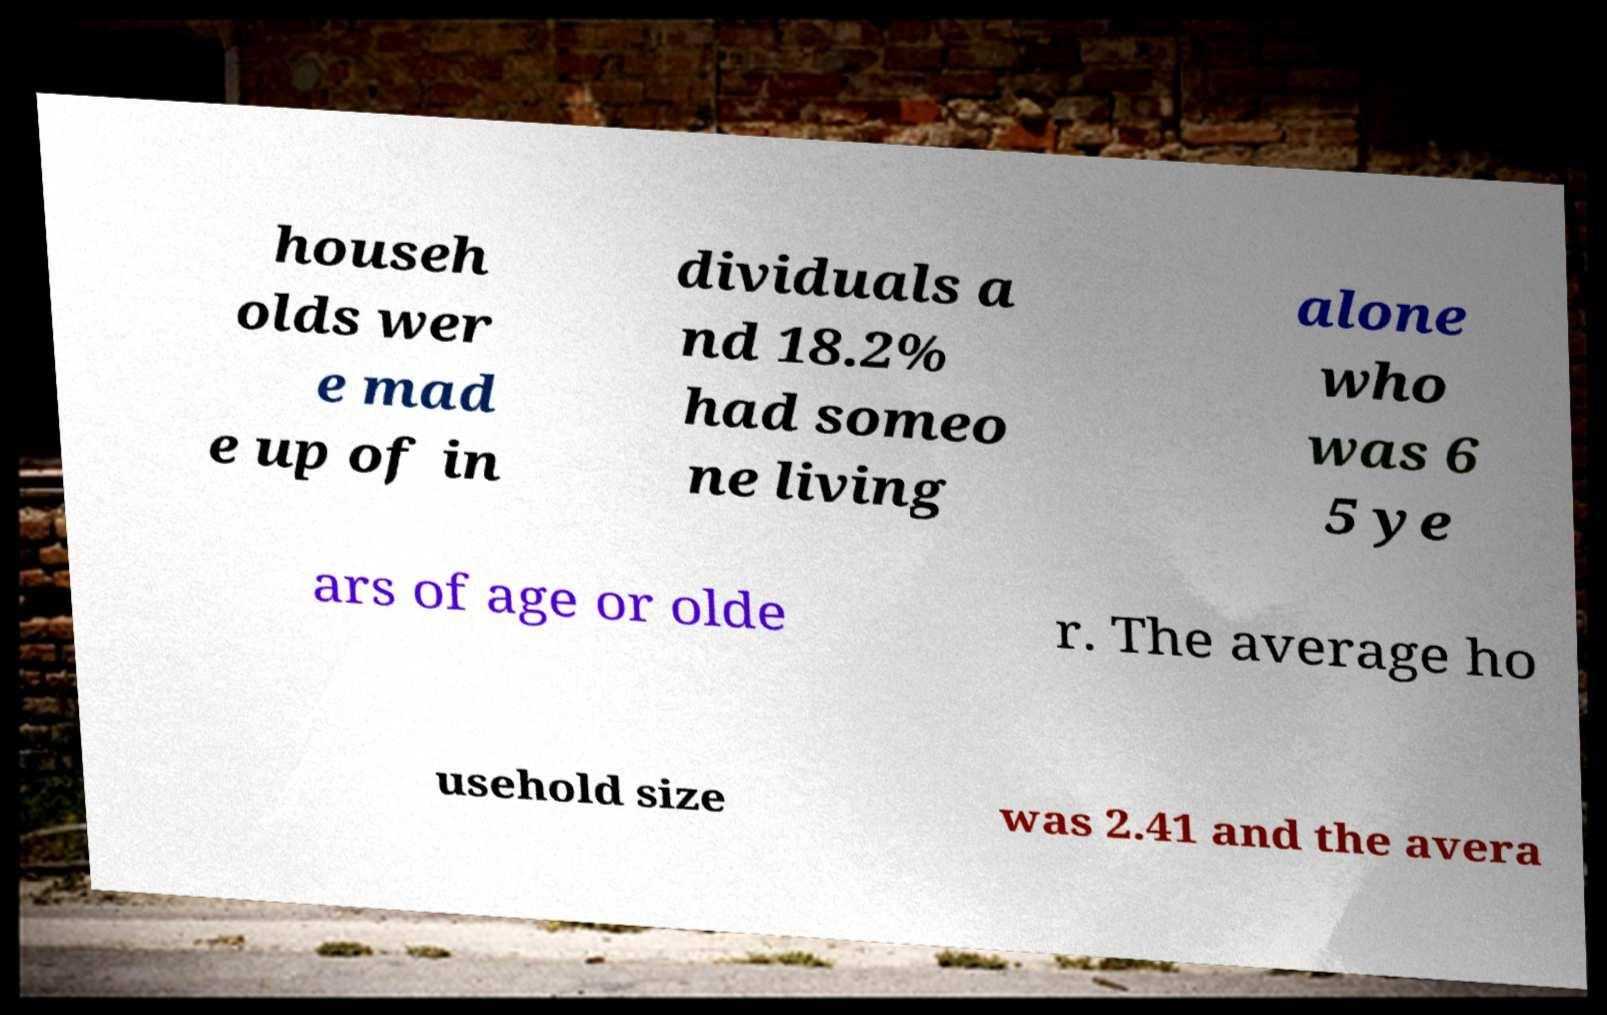I need the written content from this picture converted into text. Can you do that? househ olds wer e mad e up of in dividuals a nd 18.2% had someo ne living alone who was 6 5 ye ars of age or olde r. The average ho usehold size was 2.41 and the avera 